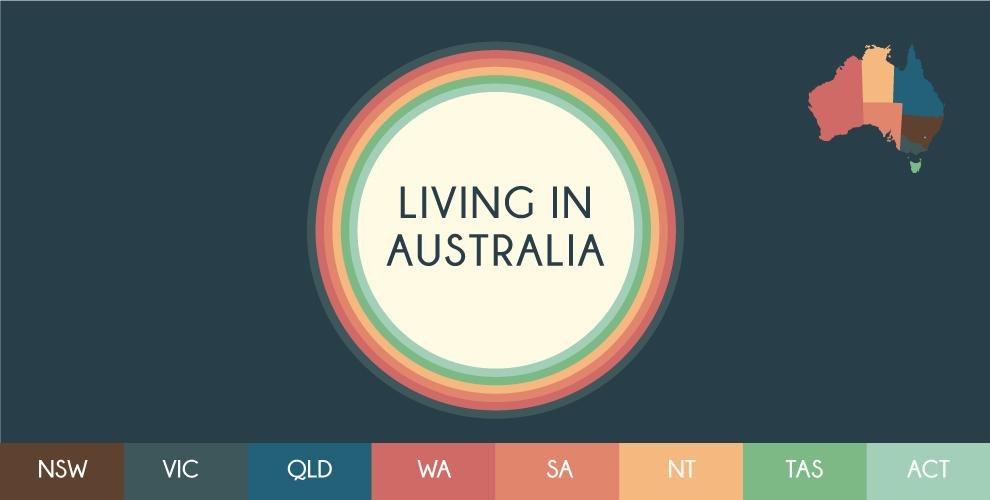Outline some significant characteristics in this image. There are 8 states in Australia. 